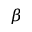Convert formula to latex. <formula><loc_0><loc_0><loc_500><loc_500>\beta</formula> 